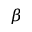Convert formula to latex. <formula><loc_0><loc_0><loc_500><loc_500>\beta</formula> 